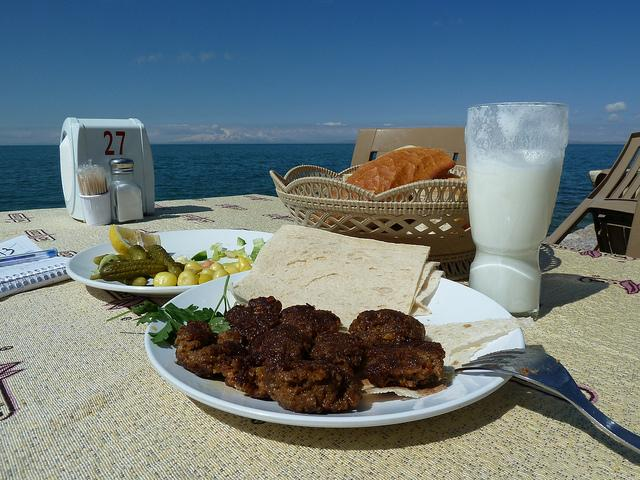Why would someone be seated here?

Choices:
A) to eat
B) to work
C) to paint
D) to wait to eat 